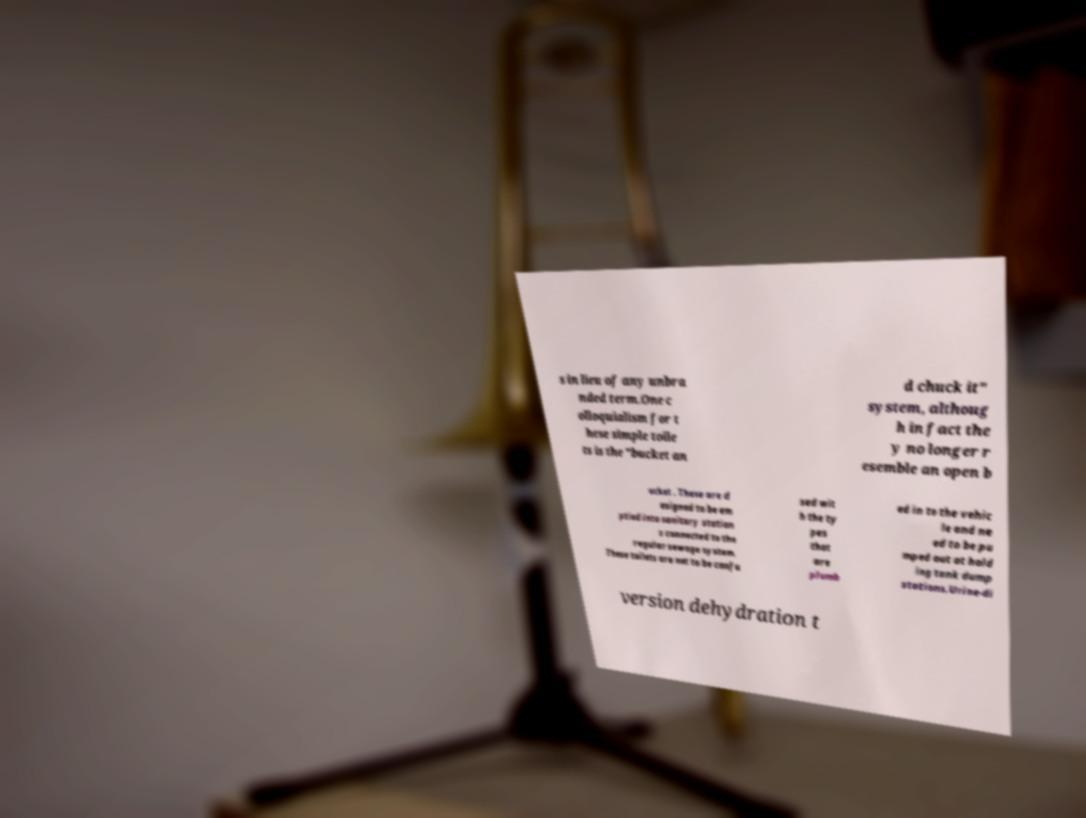Can you read and provide the text displayed in the image?This photo seems to have some interesting text. Can you extract and type it out for me? s in lieu of any unbra nded term.One c olloquialism for t hese simple toile ts is the "bucket an d chuck it" system, althoug h in fact the y no longer r esemble an open b ucket . These are d esigned to be em ptied into sanitary station s connected to the regular sewage system. These toilets are not to be confu sed wit h the ty pes that are plumb ed in to the vehic le and ne ed to be pu mped out at hold ing tank dump stations.Urine-di version dehydration t 